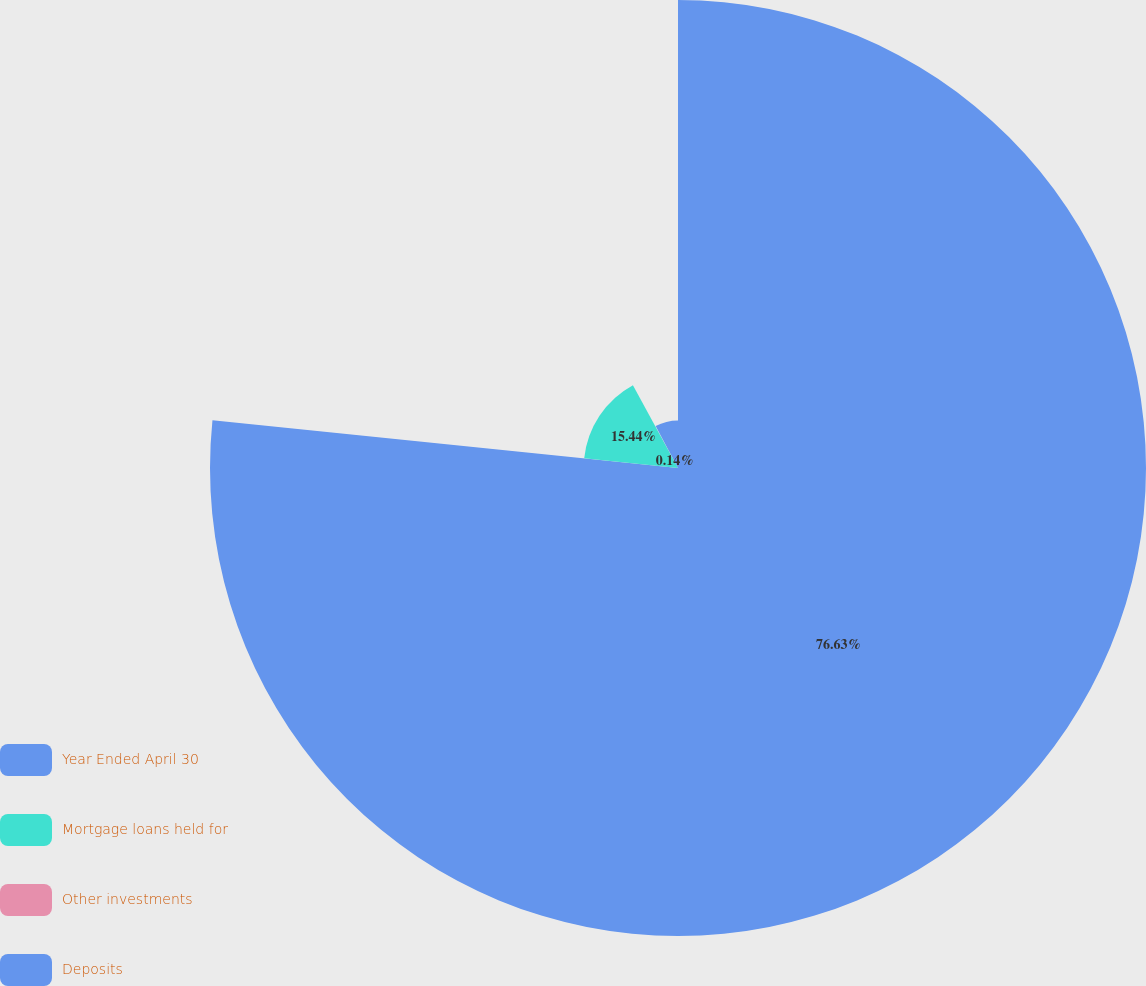Convert chart. <chart><loc_0><loc_0><loc_500><loc_500><pie_chart><fcel>Year Ended April 30<fcel>Mortgage loans held for<fcel>Other investments<fcel>Deposits<nl><fcel>76.63%<fcel>15.44%<fcel>0.14%<fcel>7.79%<nl></chart> 